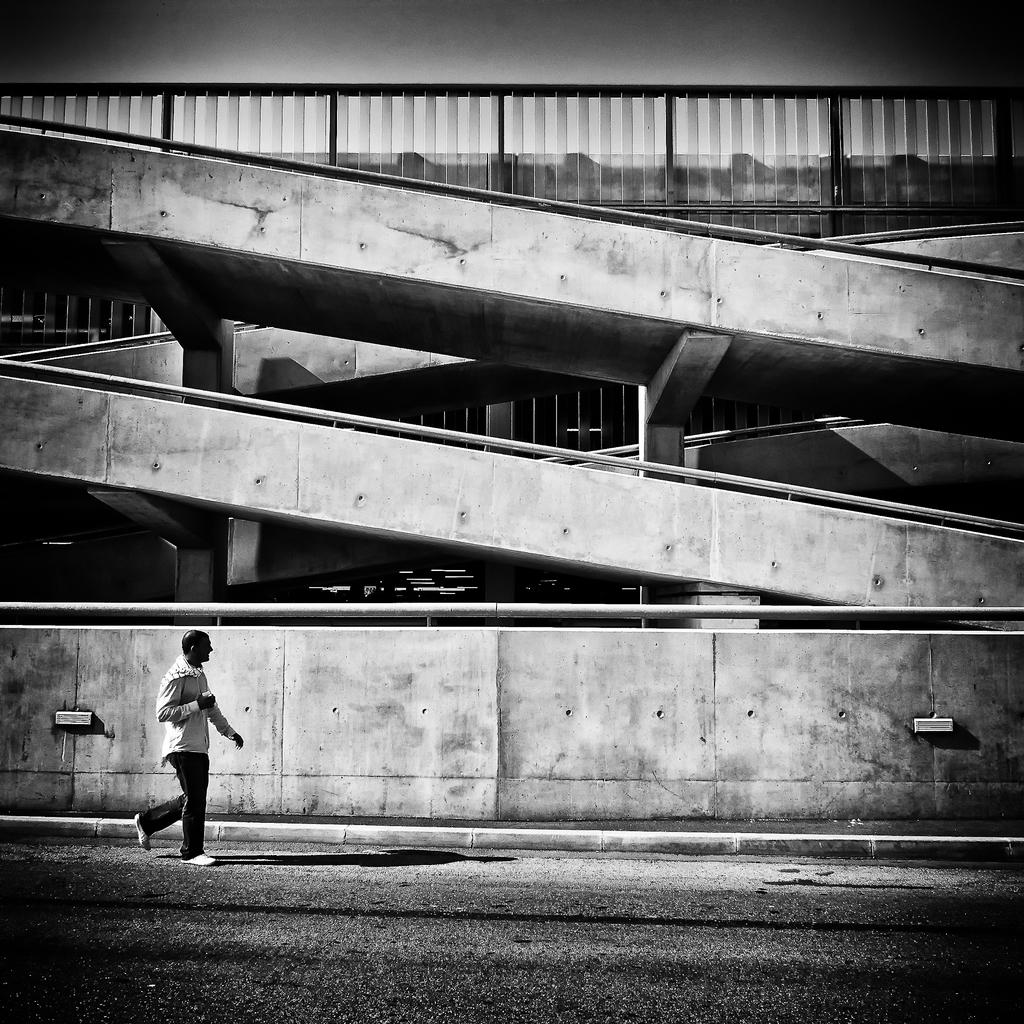What is the main structure visible in the image? There is a staircase of a building in the image. Can you describe the person in the image? A person is walking on the road in front of the building. What type of effect does the potato have on the building in the image? There is no potato present in the image, so it cannot have any effect on the building. 